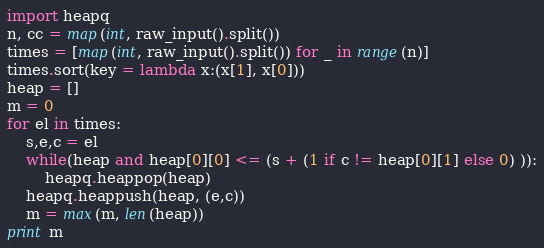Convert code to text. <code><loc_0><loc_0><loc_500><loc_500><_Python_>import heapq
n, cc = map(int, raw_input().split())
times = [map(int, raw_input().split()) for _ in range(n)]
times.sort(key = lambda x:(x[1], x[0]))
heap = []
m = 0
for el in times:
	s,e,c = el
	while(heap and heap[0][0] <= (s + (1 if c != heap[0][1] else 0) )):
		heapq.heappop(heap)
	heapq.heappush(heap, (e,c))
	m = max(m, len(heap))
print m
</code> 